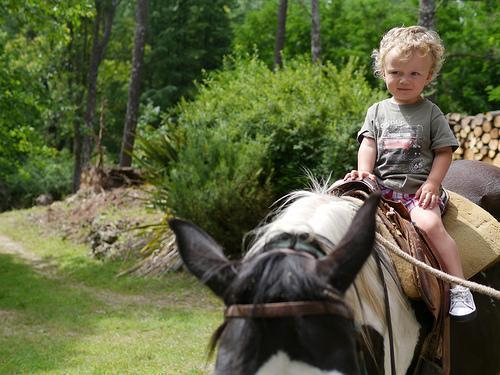How many people are in the image?
Give a very brief answer. 1. 